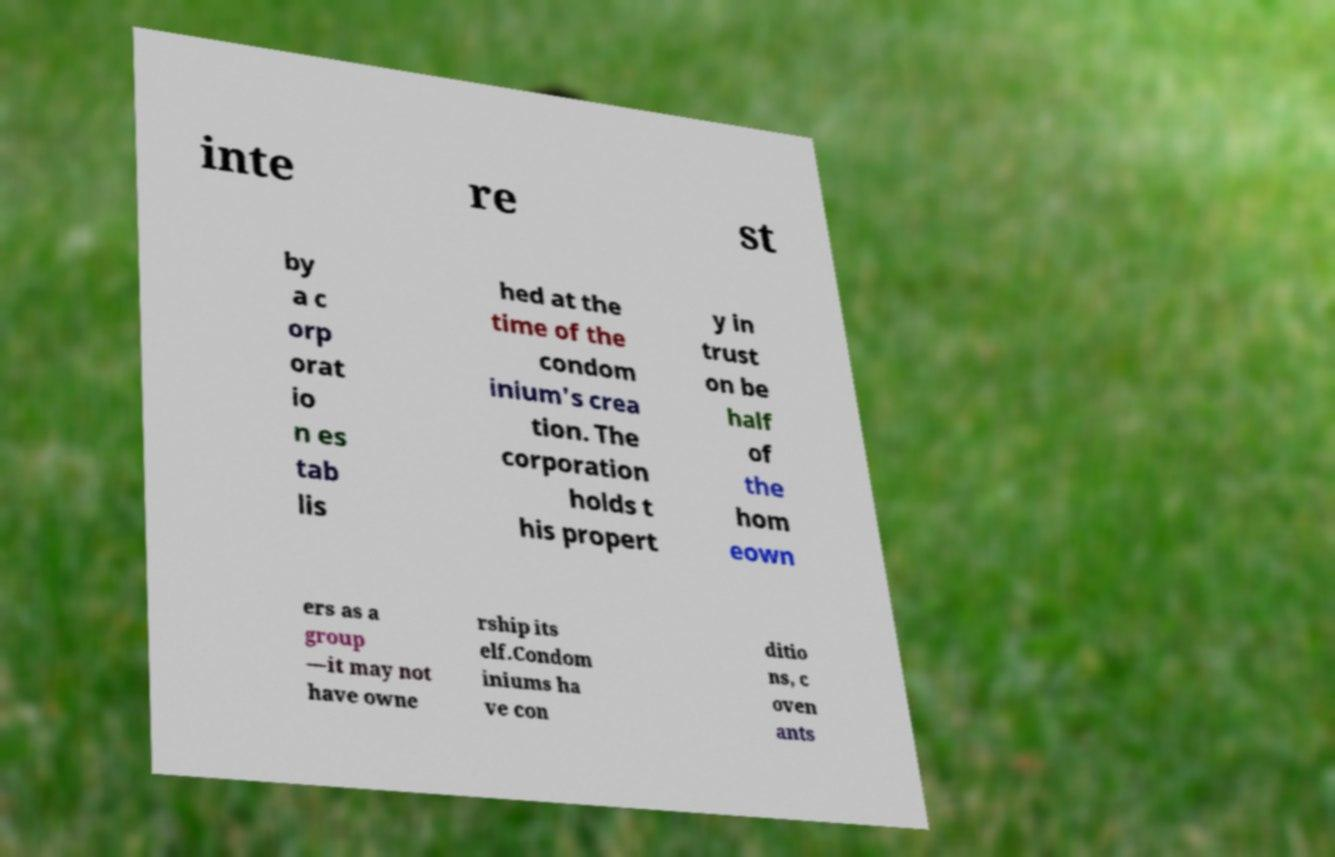Can you read and provide the text displayed in the image?This photo seems to have some interesting text. Can you extract and type it out for me? inte re st by a c orp orat io n es tab lis hed at the time of the condom inium's crea tion. The corporation holds t his propert y in trust on be half of the hom eown ers as a group —it may not have owne rship its elf.Condom iniums ha ve con ditio ns, c oven ants 